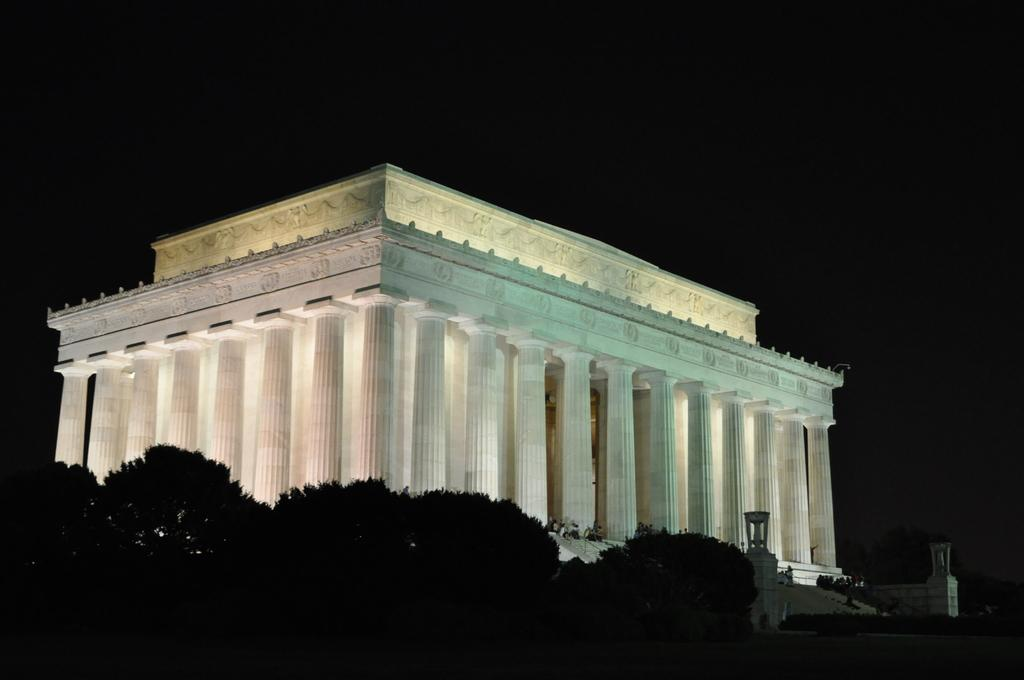What type of vegetation is at the bottom of the image? There are trees at the bottom of the image. What structure is located in the middle of the image? There is a building in the middle of the image. What type of rifle is being used by the person standing next to the building in the image? There is no person or rifle present in the image; it only features trees at the bottom and a building in the middle. 